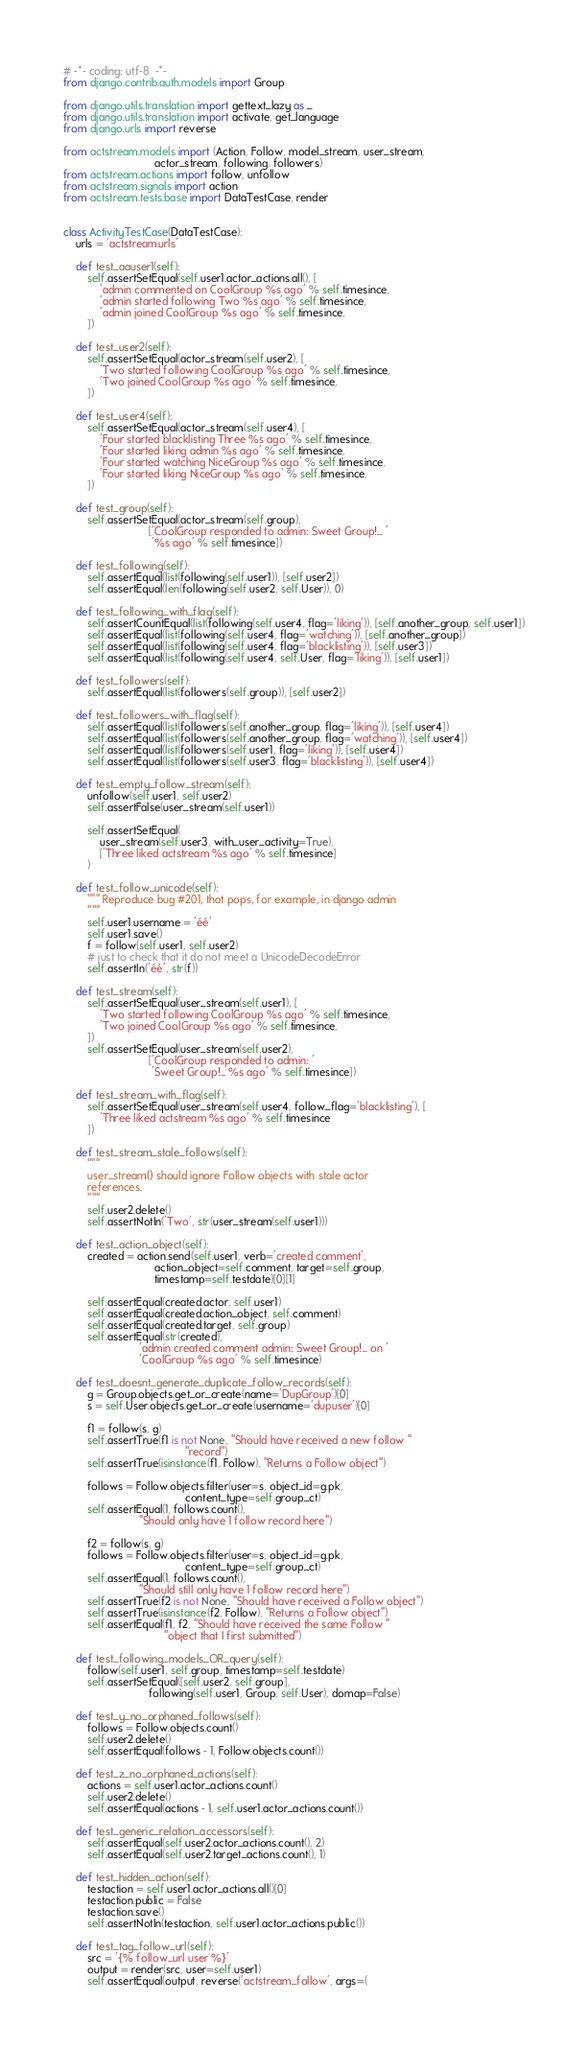<code> <loc_0><loc_0><loc_500><loc_500><_Python_># -*- coding: utf-8  -*-
from django.contrib.auth.models import Group

from django.utils.translation import gettext_lazy as _
from django.utils.translation import activate, get_language
from django.urls import reverse

from actstream.models import (Action, Follow, model_stream, user_stream,
                              actor_stream, following, followers)
from actstream.actions import follow, unfollow
from actstream.signals import action
from actstream.tests.base import DataTestCase, render


class ActivityTestCase(DataTestCase):
    urls = 'actstream.urls'

    def test_aauser1(self):
        self.assertSetEqual(self.user1.actor_actions.all(), [
            'admin commented on CoolGroup %s ago' % self.timesince,
            'admin started following Two %s ago' % self.timesince,
            'admin joined CoolGroup %s ago' % self.timesince,
        ])

    def test_user2(self):
        self.assertSetEqual(actor_stream(self.user2), [
            'Two started following CoolGroup %s ago' % self.timesince,
            'Two joined CoolGroup %s ago' % self.timesince,
        ])

    def test_user4(self):
        self.assertSetEqual(actor_stream(self.user4), [
            'Four started blacklisting Three %s ago' % self.timesince,
            'Four started liking admin %s ago' % self.timesince,
            'Four started watching NiceGroup %s ago' % self.timesince,
            'Four started liking NiceGroup %s ago' % self.timesince,
        ])

    def test_group(self):
        self.assertSetEqual(actor_stream(self.group),
                            ['CoolGroup responded to admin: Sweet Group!... '
                             '%s ago' % self.timesince])

    def test_following(self):
        self.assertEqual(list(following(self.user1)), [self.user2])
        self.assertEqual(len(following(self.user2, self.User)), 0)

    def test_following_with_flag(self):
        self.assertCountEqual(list(following(self.user4, flag='liking')), [self.another_group, self.user1])
        self.assertEqual(list(following(self.user4, flag='watching')), [self.another_group])
        self.assertEqual(list(following(self.user4, flag='blacklisting')), [self.user3])
        self.assertEqual(list(following(self.user4, self.User, flag='liking')), [self.user1])

    def test_followers(self):
        self.assertEqual(list(followers(self.group)), [self.user2])

    def test_followers_with_flag(self):
        self.assertEqual(list(followers(self.another_group, flag='liking')), [self.user4])
        self.assertEqual(list(followers(self.another_group, flag='watching')), [self.user4])
        self.assertEqual(list(followers(self.user1, flag='liking')), [self.user4])
        self.assertEqual(list(followers(self.user3, flag='blacklisting')), [self.user4])

    def test_empty_follow_stream(self):
        unfollow(self.user1, self.user2)
        self.assertFalse(user_stream(self.user1))

        self.assertSetEqual(
            user_stream(self.user3, with_user_activity=True),
            ['Three liked actstream %s ago' % self.timesince]
        )

    def test_follow_unicode(self):
        """ Reproduce bug #201, that pops, for example, in django admin
        """
        self.user1.username = 'éé'
        self.user1.save()
        f = follow(self.user1, self.user2)
        # just to check that it do not meet a UnicodeDecodeError
        self.assertIn('éé', str(f))

    def test_stream(self):
        self.assertSetEqual(user_stream(self.user1), [
            'Two started following CoolGroup %s ago' % self.timesince,
            'Two joined CoolGroup %s ago' % self.timesince,
        ])
        self.assertSetEqual(user_stream(self.user2),
                            ['CoolGroup responded to admin: '
                             'Sweet Group!... %s ago' % self.timesince])

    def test_stream_with_flag(self):
        self.assertSetEqual(user_stream(self.user4, follow_flag='blacklisting'), [
            'Three liked actstream %s ago' % self.timesince
        ])

    def test_stream_stale_follows(self):
        """
        user_stream() should ignore Follow objects with stale actor
        references.
        """
        self.user2.delete()
        self.assertNotIn('Two', str(user_stream(self.user1)))

    def test_action_object(self):
        created = action.send(self.user1, verb='created comment',
                              action_object=self.comment, target=self.group,
                              timestamp=self.testdate)[0][1]

        self.assertEqual(created.actor, self.user1)
        self.assertEqual(created.action_object, self.comment)
        self.assertEqual(created.target, self.group)
        self.assertEqual(str(created),
                         'admin created comment admin: Sweet Group!... on '
                         'CoolGroup %s ago' % self.timesince)

    def test_doesnt_generate_duplicate_follow_records(self):
        g = Group.objects.get_or_create(name='DupGroup')[0]
        s = self.User.objects.get_or_create(username='dupuser')[0]

        f1 = follow(s, g)
        self.assertTrue(f1 is not None, "Should have received a new follow "
                                        "record")
        self.assertTrue(isinstance(f1, Follow), "Returns a Follow object")

        follows = Follow.objects.filter(user=s, object_id=g.pk,
                                        content_type=self.group_ct)
        self.assertEqual(1, follows.count(),
                         "Should only have 1 follow record here")

        f2 = follow(s, g)
        follows = Follow.objects.filter(user=s, object_id=g.pk,
                                        content_type=self.group_ct)
        self.assertEqual(1, follows.count(),
                         "Should still only have 1 follow record here")
        self.assertTrue(f2 is not None, "Should have received a Follow object")
        self.assertTrue(isinstance(f2, Follow), "Returns a Follow object")
        self.assertEqual(f1, f2, "Should have received the same Follow "
                                 "object that I first submitted")

    def test_following_models_OR_query(self):
        follow(self.user1, self.group, timestamp=self.testdate)
        self.assertSetEqual([self.user2, self.group],
                            following(self.user1, Group, self.User), domap=False)

    def test_y_no_orphaned_follows(self):
        follows = Follow.objects.count()
        self.user2.delete()
        self.assertEqual(follows - 1, Follow.objects.count())

    def test_z_no_orphaned_actions(self):
        actions = self.user1.actor_actions.count()
        self.user2.delete()
        self.assertEqual(actions - 1, self.user1.actor_actions.count())

    def test_generic_relation_accessors(self):
        self.assertEqual(self.user2.actor_actions.count(), 2)
        self.assertEqual(self.user2.target_actions.count(), 1)

    def test_hidden_action(self):
        testaction = self.user1.actor_actions.all()[0]
        testaction.public = False
        testaction.save()
        self.assertNotIn(testaction, self.user1.actor_actions.public())

    def test_tag_follow_url(self):
        src = '{% follow_url user %}'
        output = render(src, user=self.user1)
        self.assertEqual(output, reverse('actstream_follow', args=(</code> 